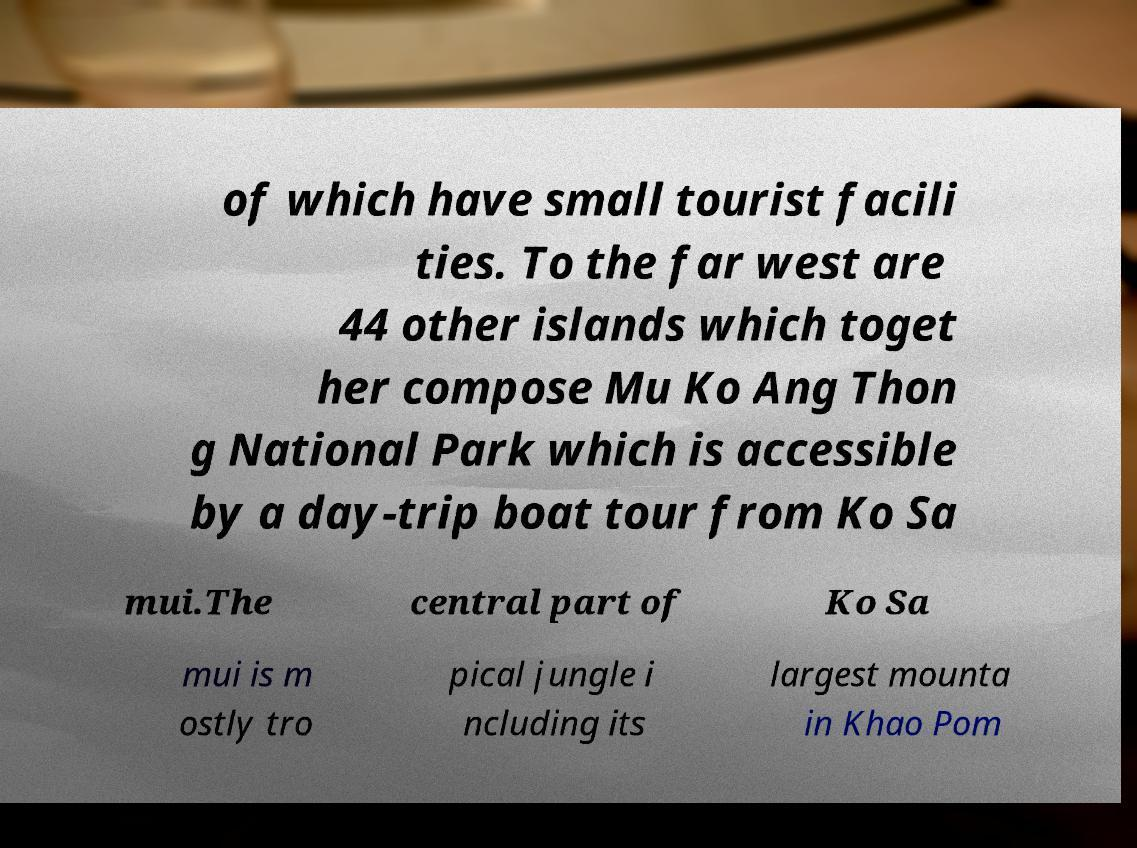Could you extract and type out the text from this image? of which have small tourist facili ties. To the far west are 44 other islands which toget her compose Mu Ko Ang Thon g National Park which is accessible by a day-trip boat tour from Ko Sa mui.The central part of Ko Sa mui is m ostly tro pical jungle i ncluding its largest mounta in Khao Pom 